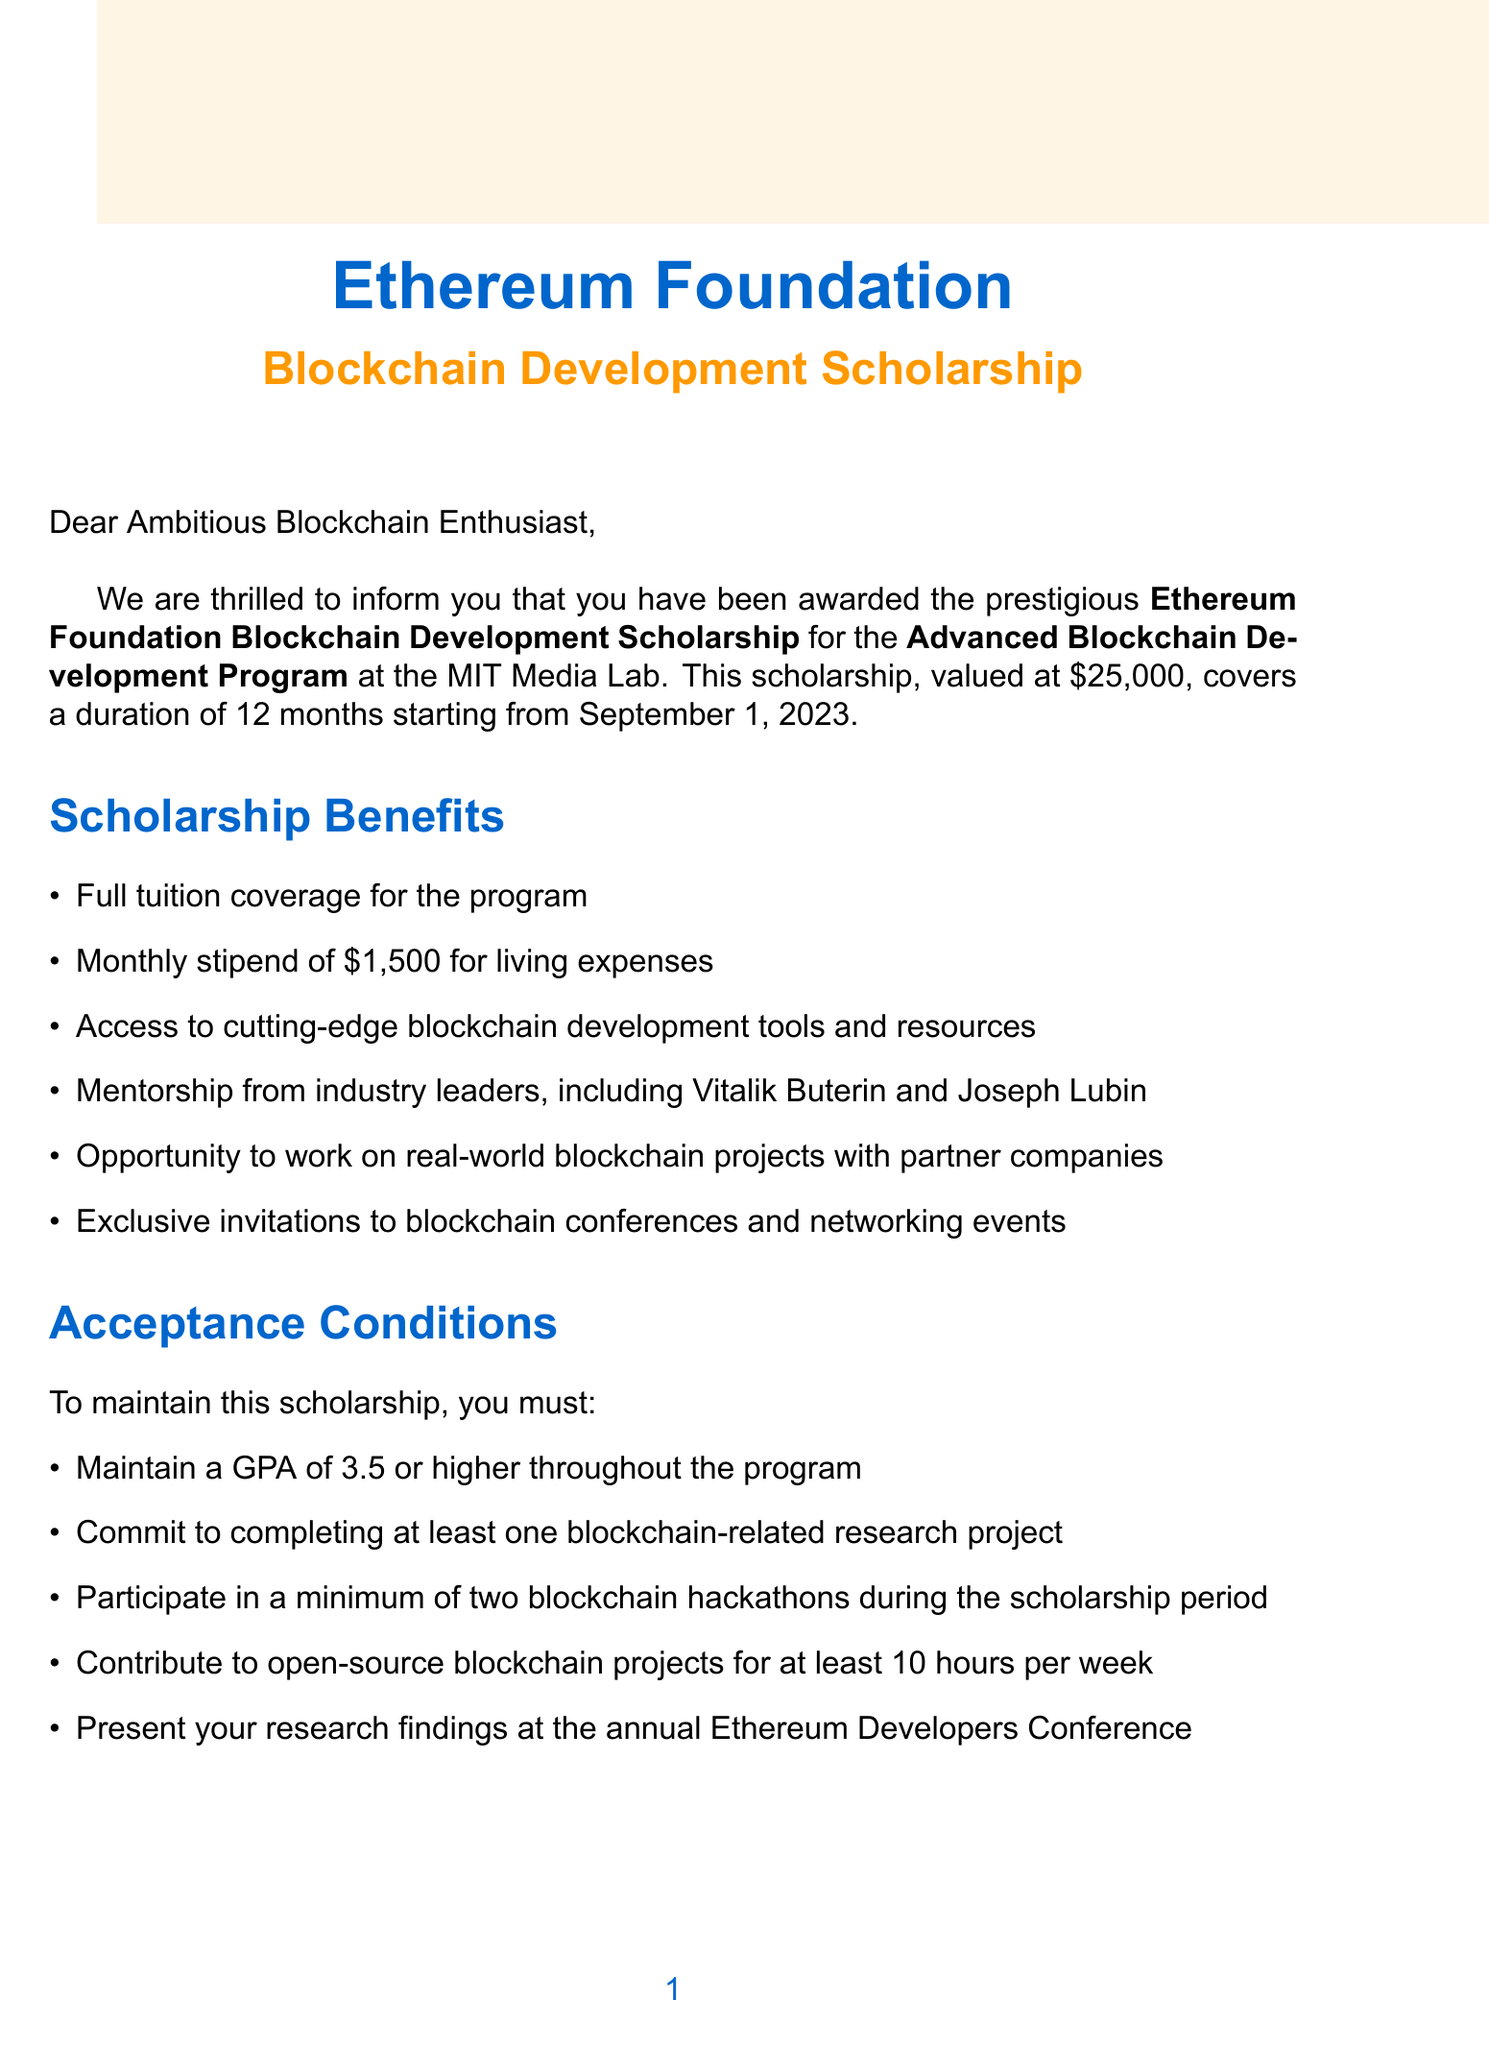What is the name of the scholarship? The scholarship is called the Ethereum Foundation Blockchain Development Scholarship.
Answer: Ethereum Foundation Blockchain Development Scholarship What is the total amount of the scholarship award? The award amount specified in the document is $25,000.
Answer: $25,000 What is the duration of the program? The document states that the duration of the program is 12 months.
Answer: 12 months Who is the contact person for the scholarship? The contact person mentioned in the document is Dr. Priya Sharma.
Answer: Dr. Priya Sharma What GPA must be maintained during the program? The document requires maintaining a GPA of 3.5 or higher throughout the program.
Answer: 3.5 How many letters of recommendation are required? The scholarship requires two letters of recommendation from blockchain industry professionals.
Answer: Two letters What is a significant opportunity provided after completing the program? The document mentions internship placement at ConsenSys after successful completion of the program.
Answer: Internship placement at ConsenSys What does the scholarship aim to nurture? The scholarship aims to nurture the next generation of blockchain innovators.
Answer: Next generation of blockchain innovators What is the deadline for acceptance? The deadline for acceptance is specified as July 15, 2023.
Answer: July 15, 2023 